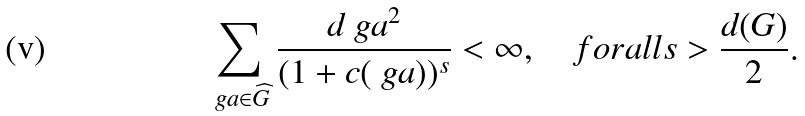<formula> <loc_0><loc_0><loc_500><loc_500>\sum _ { \ g a \in \widehat { G } } \frac { d _ { \ } g a ^ { 2 } } { ( 1 + c ( \ g a ) ) ^ { s } } < \infty , \quad f o r a l l s > \frac { d ( G ) } 2 .</formula> 